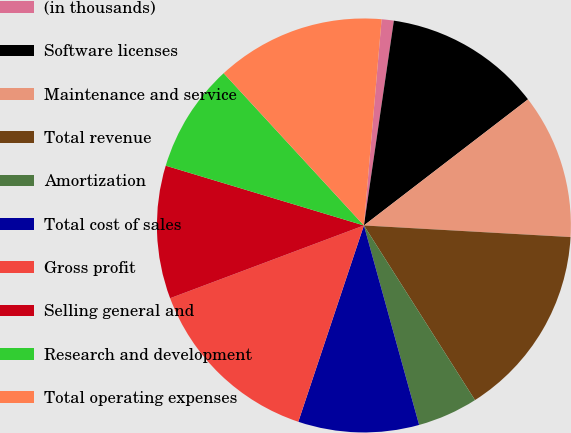Convert chart to OTSL. <chart><loc_0><loc_0><loc_500><loc_500><pie_chart><fcel>(in thousands)<fcel>Software licenses<fcel>Maintenance and service<fcel>Total revenue<fcel>Amortization<fcel>Total cost of sales<fcel>Gross profit<fcel>Selling general and<fcel>Research and development<fcel>Total operating expenses<nl><fcel>0.95%<fcel>12.26%<fcel>11.32%<fcel>15.09%<fcel>4.72%<fcel>9.43%<fcel>14.15%<fcel>10.38%<fcel>8.49%<fcel>13.21%<nl></chart> 